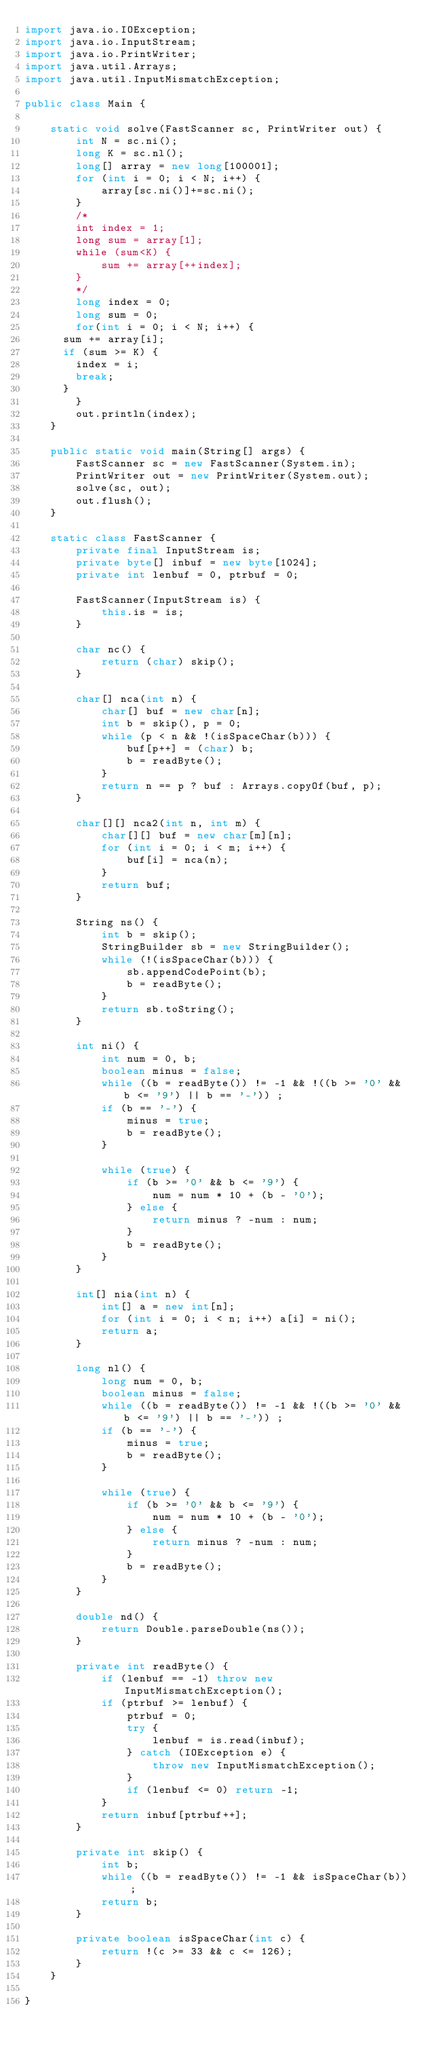Convert code to text. <code><loc_0><loc_0><loc_500><loc_500><_Java_>import java.io.IOException;
import java.io.InputStream;
import java.io.PrintWriter;
import java.util.Arrays;
import java.util.InputMismatchException;

public class Main {

    static void solve(FastScanner sc, PrintWriter out) {
        int N = sc.ni();
        long K = sc.nl();
        long[] array = new long[100001];
        for (int i = 0; i < N; i++) {
            array[sc.ni()]+=sc.ni();
        }
        /*
        int index = 1;
        long sum = array[1];
        while (sum<K) {
            sum += array[++index];
        }
        */
        long index = 0;
        long sum = 0;
        for(int i = 0; i < N; i++) {
			sum += array[i];
			if (sum >= K) {
				index = i;
				break;
			}
        }
        out.println(index);
    }

    public static void main(String[] args) {
        FastScanner sc = new FastScanner(System.in);
        PrintWriter out = new PrintWriter(System.out);
        solve(sc, out);
        out.flush();
    }

    static class FastScanner {
        private final InputStream is;
        private byte[] inbuf = new byte[1024];
        private int lenbuf = 0, ptrbuf = 0;

        FastScanner(InputStream is) {
            this.is = is;
        }

        char nc() {
            return (char) skip();
        }

        char[] nca(int n) {
            char[] buf = new char[n];
            int b = skip(), p = 0;
            while (p < n && !(isSpaceChar(b))) {
                buf[p++] = (char) b;
                b = readByte();
            }
            return n == p ? buf : Arrays.copyOf(buf, p);
        }

        char[][] nca2(int n, int m) {
            char[][] buf = new char[m][n];
            for (int i = 0; i < m; i++) {
                buf[i] = nca(n);
            }
            return buf;
        }

        String ns() {
            int b = skip();
            StringBuilder sb = new StringBuilder();
            while (!(isSpaceChar(b))) {
                sb.appendCodePoint(b);
                b = readByte();
            }
            return sb.toString();
        }

        int ni() {
            int num = 0, b;
            boolean minus = false;
            while ((b = readByte()) != -1 && !((b >= '0' && b <= '9') || b == '-')) ;
            if (b == '-') {
                minus = true;
                b = readByte();
            }

            while (true) {
                if (b >= '0' && b <= '9') {
                    num = num * 10 + (b - '0');
                } else {
                    return minus ? -num : num;
                }
                b = readByte();
            }
        }

        int[] nia(int n) {
            int[] a = new int[n];
            for (int i = 0; i < n; i++) a[i] = ni();
            return a;
        }

        long nl() {
            long num = 0, b;
            boolean minus = false;
            while ((b = readByte()) != -1 && !((b >= '0' && b <= '9') || b == '-')) ;
            if (b == '-') {
                minus = true;
                b = readByte();
            }

            while (true) {
                if (b >= '0' && b <= '9') {
                    num = num * 10 + (b - '0');
                } else {
                    return minus ? -num : num;
                }
                b = readByte();
            }
        }

        double nd() {
            return Double.parseDouble(ns());
        }

        private int readByte() {
            if (lenbuf == -1) throw new InputMismatchException();
            if (ptrbuf >= lenbuf) {
                ptrbuf = 0;
                try {
                    lenbuf = is.read(inbuf);
                } catch (IOException e) {
                    throw new InputMismatchException();
                }
                if (lenbuf <= 0) return -1;
            }
            return inbuf[ptrbuf++];
        }

        private int skip() {
            int b;
            while ((b = readByte()) != -1 && isSpaceChar(b)) ;
            return b;
        }

        private boolean isSpaceChar(int c) {
            return !(c >= 33 && c <= 126);
        }
    }

}
</code> 